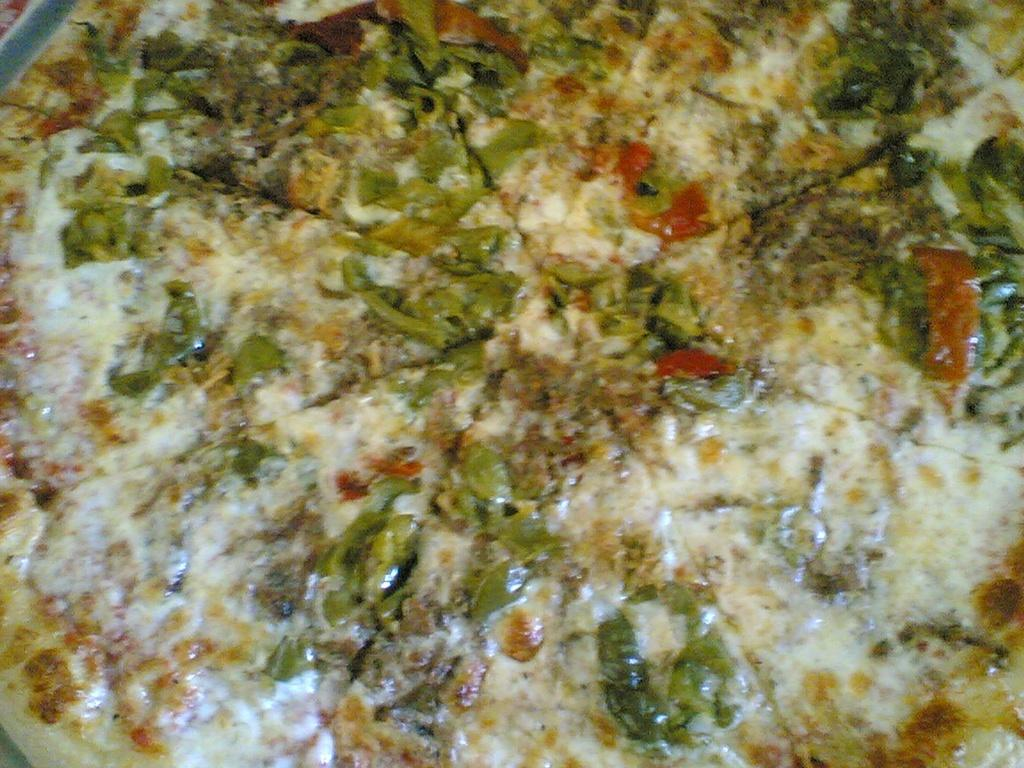What is present in the image? There is food in the image. Can you see a snail working on the road in the image? There is no snail or road present in the image; it only features food. 